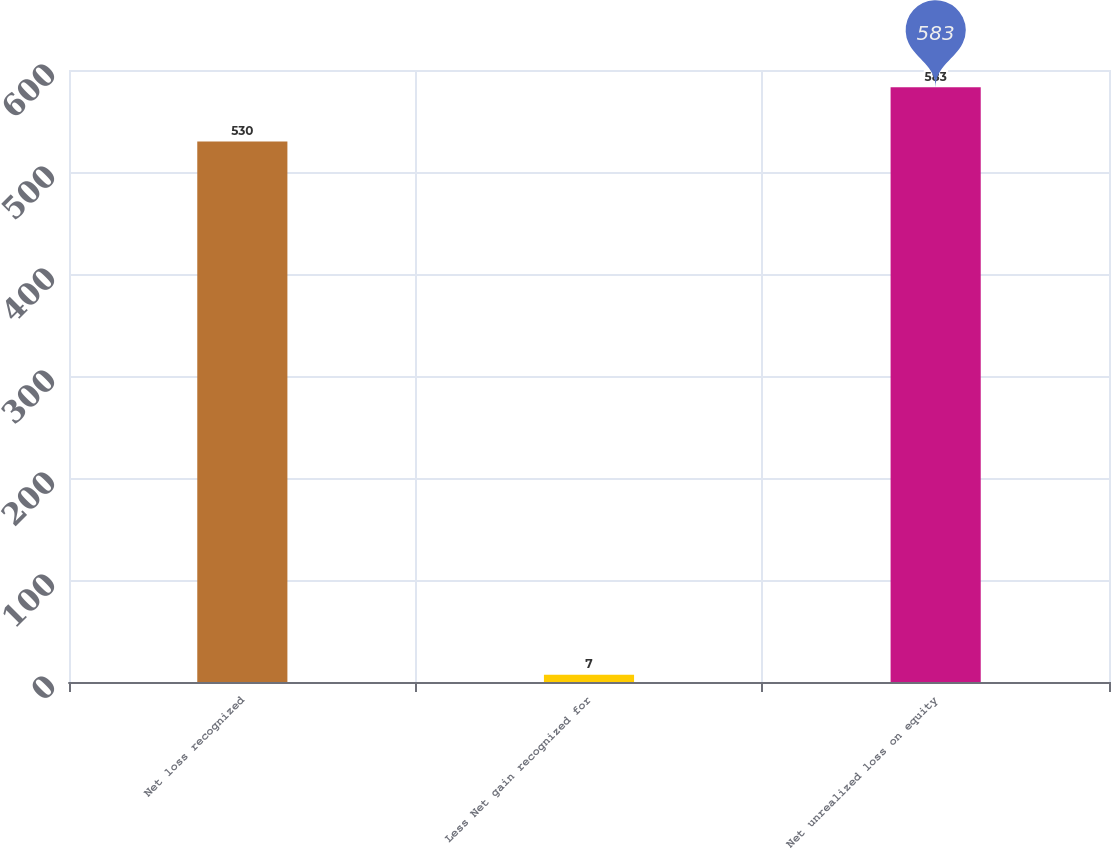Convert chart. <chart><loc_0><loc_0><loc_500><loc_500><bar_chart><fcel>Net loss recognized<fcel>Less Net gain recognized for<fcel>Net unrealized loss on equity<nl><fcel>530<fcel>7<fcel>583<nl></chart> 